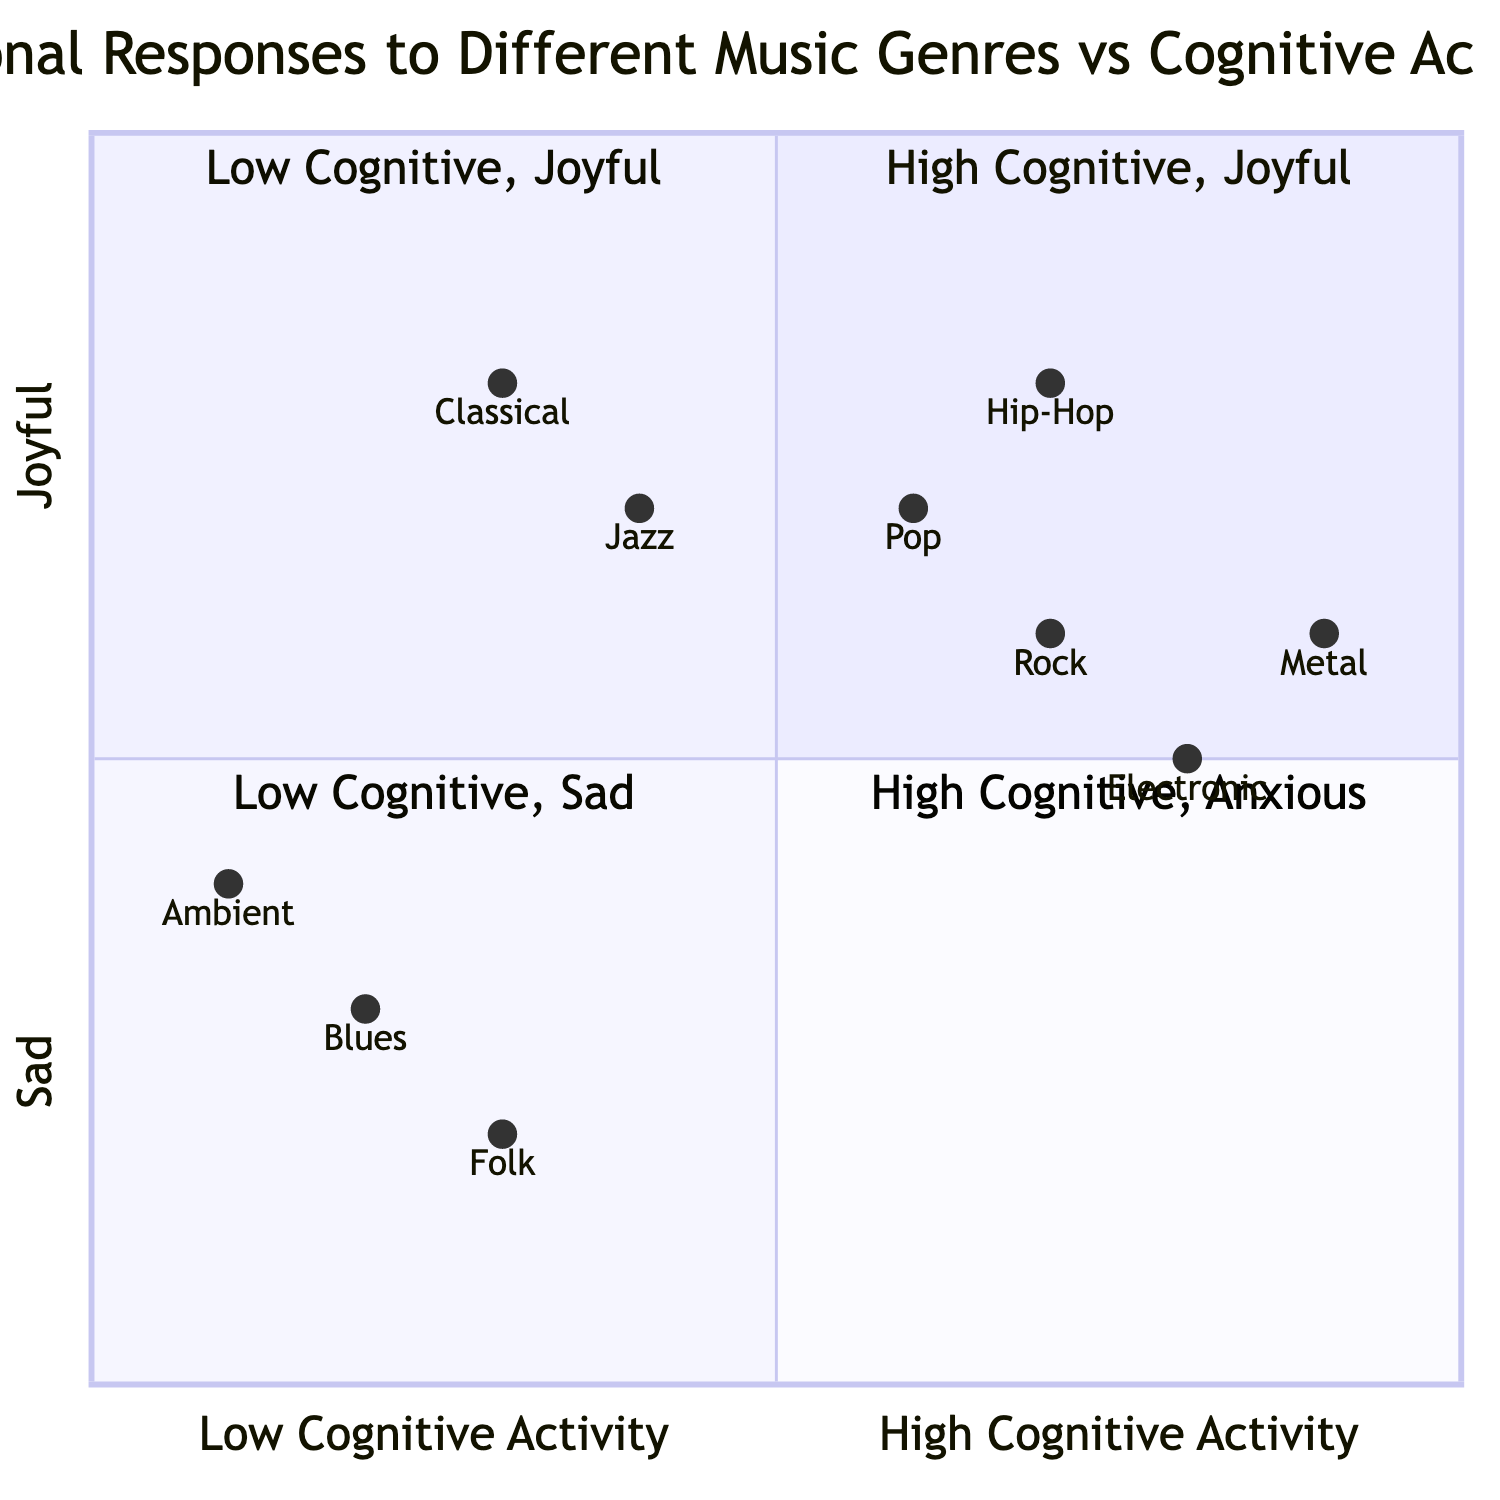What is the emotional response associated with the genre "Jazz"? According to the diagram, Jazz is located in Quadrants 1 and 2, which correspond to the emotional responses of "Joyful" and "Calm." Therefore, the emotional response associated with Jazz is Joyful.
Answer: Joyful Which genre has a high cognitive activity and evokes a sad emotional response? The diagram shows that sad emotions are noted in Quadrant 3 (High Cognitive activity + Sad), but no genre is listed in that quadrant, indicating there is none that fits this criteria.
Answer: None How many music genres are associated with joyful emotional responses? The genres that fall in the joyful emotional category include Classical, Jazz, Rock, Electronic, Pop, and Hip-Hop, which totals to 6 genres.
Answer: 6 What cognitive activity is associated with the Blues genre? The Blues genre is listed under Quadrants 2 and 4. Quadrant 2 indicates "Low" cognitive activity. Hence, the cognitive activity for Blues is "Low."
Answer: Low Which genre appears to have the highest cognitive activity? The genre located furthest to the right in the diagram is Metal, which is in Quadrant 1 and has the highest value on the cognitive activity scale, indicating it has the highest cognitive activity.
Answer: Metal In which quadrant do Rock and Electronic both appear? Both Rock and Electronic are found in Quadrant 1, where there is a high cognitive activity and joyful emotional response.
Answer: Quadrant 1 What is the emotional response associated with the lowest cognitive activity? According to the diagram, genres that have low cognitive activity (Quadrants 2 and 4) evoke emotional responses of "Calm" and "Sad." Therefore, the emotions tied to low cognitive activity are Calm and Sad.
Answer: Calm and Sad How does the emotional response of Folk compare to Blues? Folk is categorized in Quadrants 2 and 4, experiencing "Calm" and "Sad" emotions. Blues, which is also in Quadrants 2 and 4, has similar emotional responses of "Calm" and "Sad." Thus, their emotional responses are the same.
Answer: Same Which two genres evoke anxious feelings along with high cognitive activity? The genres listed in Quadrant 4 are Rock, Electronic, Pop, Hip-Hop, and Metal, all eliciting anxious feelings. Therefore, these genres that accompany anxious emotional responses to high cognitive activity are Rock, Electronic, and others.
Answer: Rock, Electronic, Pop, Hip-Hop, Metal 